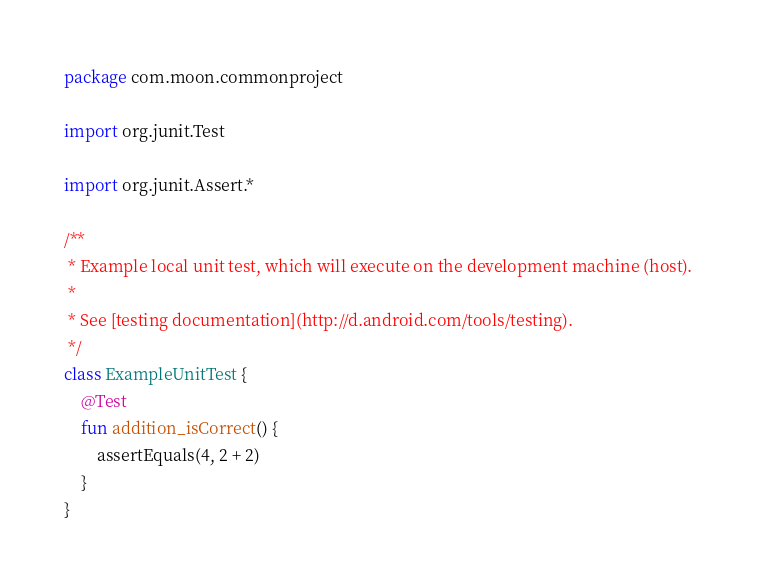<code> <loc_0><loc_0><loc_500><loc_500><_Kotlin_>package com.moon.commonproject

import org.junit.Test

import org.junit.Assert.*

/**
 * Example local unit test, which will execute on the development machine (host).
 *
 * See [testing documentation](http://d.android.com/tools/testing).
 */
class ExampleUnitTest {
    @Test
    fun addition_isCorrect() {
        assertEquals(4, 2 + 2)
    }
}</code> 